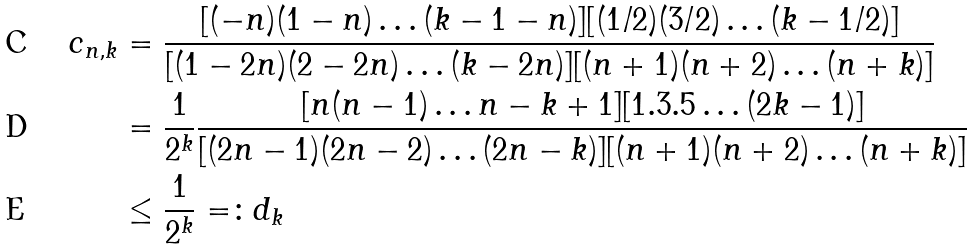Convert formula to latex. <formula><loc_0><loc_0><loc_500><loc_500>c _ { n , k } & = \frac { [ ( - n ) ( 1 - n ) \dots ( k - 1 - n ) ] [ ( 1 / 2 ) ( 3 / 2 ) \dots ( k - 1 / 2 ) ] } { [ ( 1 - 2 n ) ( 2 - 2 n ) \dots ( k - 2 n ) ] [ ( n + 1 ) ( n + 2 ) \dots ( n + k ) ] } \\ & = \frac { 1 } { 2 ^ { k } } \frac { [ n ( n - 1 ) \dots n - k + 1 ] [ 1 . 3 . 5 \dots ( 2 k - 1 ) ] } { [ ( 2 n - 1 ) ( 2 n - 2 ) \dots ( 2 n - k ) ] [ ( n + 1 ) ( n + 2 ) \dots ( n + k ) ] } \\ & \leq \frac { 1 } { 2 ^ { k } } = \colon d _ { k }</formula> 